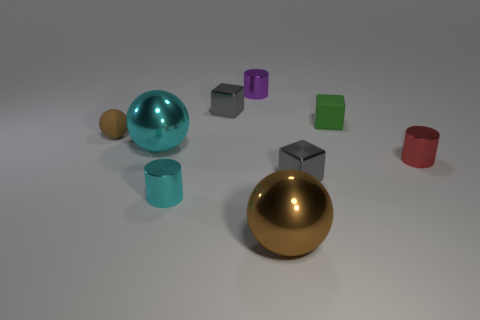Is the number of purple objects less than the number of tiny green rubber cylinders?
Your answer should be very brief. No. There is a small cylinder that is behind the large thing that is left of the small gray cube behind the small brown thing; what is it made of?
Your answer should be compact. Metal. What is the material of the small brown object?
Your response must be concise. Rubber. There is a cube that is in front of the small rubber ball; does it have the same color as the metal cylinder behind the tiny green matte thing?
Provide a short and direct response. No. Are there more spheres than purple shiny cylinders?
Provide a short and direct response. Yes. What number of other metallic spheres are the same color as the small ball?
Give a very brief answer. 1. There is another large thing that is the same shape as the big cyan thing; what is its color?
Make the answer very short. Brown. The tiny cylinder that is in front of the green block and to the left of the large brown shiny thing is made of what material?
Provide a succinct answer. Metal. Does the small cube in front of the green object have the same material as the large object behind the small red metallic object?
Your response must be concise. Yes. What is the size of the matte sphere?
Ensure brevity in your answer.  Small. 